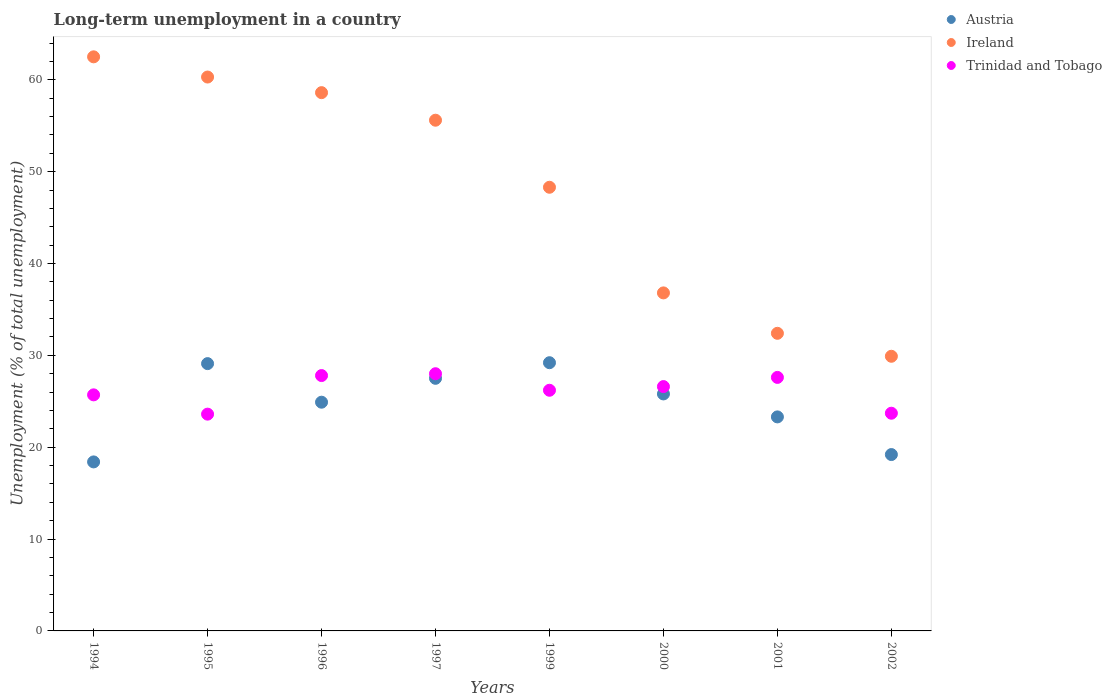Is the number of dotlines equal to the number of legend labels?
Offer a very short reply. Yes. What is the percentage of long-term unemployed population in Ireland in 1997?
Your response must be concise. 55.6. Across all years, what is the maximum percentage of long-term unemployed population in Trinidad and Tobago?
Ensure brevity in your answer.  28. Across all years, what is the minimum percentage of long-term unemployed population in Austria?
Ensure brevity in your answer.  18.4. What is the total percentage of long-term unemployed population in Trinidad and Tobago in the graph?
Make the answer very short. 209.2. What is the difference between the percentage of long-term unemployed population in Trinidad and Tobago in 2001 and that in 2002?
Offer a terse response. 3.9. What is the difference between the percentage of long-term unemployed population in Ireland in 2001 and the percentage of long-term unemployed population in Trinidad and Tobago in 1996?
Provide a succinct answer. 4.6. What is the average percentage of long-term unemployed population in Trinidad and Tobago per year?
Make the answer very short. 26.15. In the year 1994, what is the difference between the percentage of long-term unemployed population in Austria and percentage of long-term unemployed population in Trinidad and Tobago?
Provide a short and direct response. -7.3. In how many years, is the percentage of long-term unemployed population in Trinidad and Tobago greater than 26 %?
Give a very brief answer. 5. What is the ratio of the percentage of long-term unemployed population in Austria in 1999 to that in 2000?
Keep it short and to the point. 1.13. What is the difference between the highest and the second highest percentage of long-term unemployed population in Ireland?
Ensure brevity in your answer.  2.2. What is the difference between the highest and the lowest percentage of long-term unemployed population in Austria?
Provide a succinct answer. 10.8. Is the sum of the percentage of long-term unemployed population in Trinidad and Tobago in 1994 and 1999 greater than the maximum percentage of long-term unemployed population in Austria across all years?
Your answer should be compact. Yes. Does the percentage of long-term unemployed population in Ireland monotonically increase over the years?
Make the answer very short. No. Is the percentage of long-term unemployed population in Trinidad and Tobago strictly greater than the percentage of long-term unemployed population in Austria over the years?
Offer a terse response. No. Is the percentage of long-term unemployed population in Trinidad and Tobago strictly less than the percentage of long-term unemployed population in Austria over the years?
Provide a short and direct response. No. How many years are there in the graph?
Your response must be concise. 8. What is the difference between two consecutive major ticks on the Y-axis?
Offer a terse response. 10. Are the values on the major ticks of Y-axis written in scientific E-notation?
Your answer should be very brief. No. Does the graph contain grids?
Offer a terse response. No. Where does the legend appear in the graph?
Make the answer very short. Top right. How many legend labels are there?
Keep it short and to the point. 3. What is the title of the graph?
Offer a very short reply. Long-term unemployment in a country. Does "Sint Maarten (Dutch part)" appear as one of the legend labels in the graph?
Your response must be concise. No. What is the label or title of the Y-axis?
Keep it short and to the point. Unemployment (% of total unemployment). What is the Unemployment (% of total unemployment) of Austria in 1994?
Your answer should be very brief. 18.4. What is the Unemployment (% of total unemployment) of Ireland in 1994?
Provide a succinct answer. 62.5. What is the Unemployment (% of total unemployment) in Trinidad and Tobago in 1994?
Give a very brief answer. 25.7. What is the Unemployment (% of total unemployment) in Austria in 1995?
Make the answer very short. 29.1. What is the Unemployment (% of total unemployment) of Ireland in 1995?
Offer a very short reply. 60.3. What is the Unemployment (% of total unemployment) in Trinidad and Tobago in 1995?
Keep it short and to the point. 23.6. What is the Unemployment (% of total unemployment) in Austria in 1996?
Ensure brevity in your answer.  24.9. What is the Unemployment (% of total unemployment) in Ireland in 1996?
Your response must be concise. 58.6. What is the Unemployment (% of total unemployment) in Trinidad and Tobago in 1996?
Make the answer very short. 27.8. What is the Unemployment (% of total unemployment) in Ireland in 1997?
Your answer should be very brief. 55.6. What is the Unemployment (% of total unemployment) in Trinidad and Tobago in 1997?
Ensure brevity in your answer.  28. What is the Unemployment (% of total unemployment) of Austria in 1999?
Your answer should be very brief. 29.2. What is the Unemployment (% of total unemployment) in Ireland in 1999?
Make the answer very short. 48.3. What is the Unemployment (% of total unemployment) of Trinidad and Tobago in 1999?
Offer a terse response. 26.2. What is the Unemployment (% of total unemployment) of Austria in 2000?
Give a very brief answer. 25.8. What is the Unemployment (% of total unemployment) of Ireland in 2000?
Make the answer very short. 36.8. What is the Unemployment (% of total unemployment) in Trinidad and Tobago in 2000?
Your answer should be very brief. 26.6. What is the Unemployment (% of total unemployment) in Austria in 2001?
Give a very brief answer. 23.3. What is the Unemployment (% of total unemployment) of Ireland in 2001?
Your response must be concise. 32.4. What is the Unemployment (% of total unemployment) in Trinidad and Tobago in 2001?
Ensure brevity in your answer.  27.6. What is the Unemployment (% of total unemployment) in Austria in 2002?
Give a very brief answer. 19.2. What is the Unemployment (% of total unemployment) in Ireland in 2002?
Your response must be concise. 29.9. What is the Unemployment (% of total unemployment) in Trinidad and Tobago in 2002?
Offer a terse response. 23.7. Across all years, what is the maximum Unemployment (% of total unemployment) in Austria?
Provide a short and direct response. 29.2. Across all years, what is the maximum Unemployment (% of total unemployment) in Ireland?
Keep it short and to the point. 62.5. Across all years, what is the maximum Unemployment (% of total unemployment) of Trinidad and Tobago?
Your answer should be very brief. 28. Across all years, what is the minimum Unemployment (% of total unemployment) of Austria?
Ensure brevity in your answer.  18.4. Across all years, what is the minimum Unemployment (% of total unemployment) of Ireland?
Offer a very short reply. 29.9. Across all years, what is the minimum Unemployment (% of total unemployment) in Trinidad and Tobago?
Make the answer very short. 23.6. What is the total Unemployment (% of total unemployment) of Austria in the graph?
Make the answer very short. 197.4. What is the total Unemployment (% of total unemployment) of Ireland in the graph?
Provide a succinct answer. 384.4. What is the total Unemployment (% of total unemployment) in Trinidad and Tobago in the graph?
Keep it short and to the point. 209.2. What is the difference between the Unemployment (% of total unemployment) of Austria in 1994 and that in 1995?
Your answer should be compact. -10.7. What is the difference between the Unemployment (% of total unemployment) of Ireland in 1994 and that in 1995?
Provide a succinct answer. 2.2. What is the difference between the Unemployment (% of total unemployment) in Ireland in 1994 and that in 1996?
Ensure brevity in your answer.  3.9. What is the difference between the Unemployment (% of total unemployment) in Trinidad and Tobago in 1994 and that in 1996?
Provide a short and direct response. -2.1. What is the difference between the Unemployment (% of total unemployment) of Ireland in 1994 and that in 1997?
Your answer should be compact. 6.9. What is the difference between the Unemployment (% of total unemployment) in Trinidad and Tobago in 1994 and that in 1997?
Ensure brevity in your answer.  -2.3. What is the difference between the Unemployment (% of total unemployment) in Austria in 1994 and that in 1999?
Ensure brevity in your answer.  -10.8. What is the difference between the Unemployment (% of total unemployment) in Austria in 1994 and that in 2000?
Your response must be concise. -7.4. What is the difference between the Unemployment (% of total unemployment) in Ireland in 1994 and that in 2000?
Your response must be concise. 25.7. What is the difference between the Unemployment (% of total unemployment) in Trinidad and Tobago in 1994 and that in 2000?
Ensure brevity in your answer.  -0.9. What is the difference between the Unemployment (% of total unemployment) in Austria in 1994 and that in 2001?
Offer a terse response. -4.9. What is the difference between the Unemployment (% of total unemployment) in Ireland in 1994 and that in 2001?
Give a very brief answer. 30.1. What is the difference between the Unemployment (% of total unemployment) in Trinidad and Tobago in 1994 and that in 2001?
Your answer should be very brief. -1.9. What is the difference between the Unemployment (% of total unemployment) of Austria in 1994 and that in 2002?
Offer a terse response. -0.8. What is the difference between the Unemployment (% of total unemployment) in Ireland in 1994 and that in 2002?
Your response must be concise. 32.6. What is the difference between the Unemployment (% of total unemployment) in Trinidad and Tobago in 1994 and that in 2002?
Your answer should be very brief. 2. What is the difference between the Unemployment (% of total unemployment) in Austria in 1995 and that in 1996?
Offer a terse response. 4.2. What is the difference between the Unemployment (% of total unemployment) of Ireland in 1995 and that in 1996?
Your answer should be very brief. 1.7. What is the difference between the Unemployment (% of total unemployment) in Ireland in 1995 and that in 1997?
Give a very brief answer. 4.7. What is the difference between the Unemployment (% of total unemployment) in Trinidad and Tobago in 1995 and that in 1997?
Ensure brevity in your answer.  -4.4. What is the difference between the Unemployment (% of total unemployment) of Austria in 1995 and that in 1999?
Ensure brevity in your answer.  -0.1. What is the difference between the Unemployment (% of total unemployment) of Trinidad and Tobago in 1995 and that in 1999?
Provide a short and direct response. -2.6. What is the difference between the Unemployment (% of total unemployment) in Trinidad and Tobago in 1995 and that in 2000?
Ensure brevity in your answer.  -3. What is the difference between the Unemployment (% of total unemployment) in Austria in 1995 and that in 2001?
Offer a terse response. 5.8. What is the difference between the Unemployment (% of total unemployment) of Ireland in 1995 and that in 2001?
Your response must be concise. 27.9. What is the difference between the Unemployment (% of total unemployment) in Ireland in 1995 and that in 2002?
Provide a succinct answer. 30.4. What is the difference between the Unemployment (% of total unemployment) in Trinidad and Tobago in 1995 and that in 2002?
Your answer should be very brief. -0.1. What is the difference between the Unemployment (% of total unemployment) in Austria in 1996 and that in 1997?
Offer a terse response. -2.6. What is the difference between the Unemployment (% of total unemployment) of Trinidad and Tobago in 1996 and that in 1997?
Keep it short and to the point. -0.2. What is the difference between the Unemployment (% of total unemployment) in Austria in 1996 and that in 1999?
Ensure brevity in your answer.  -4.3. What is the difference between the Unemployment (% of total unemployment) of Ireland in 1996 and that in 1999?
Your response must be concise. 10.3. What is the difference between the Unemployment (% of total unemployment) in Trinidad and Tobago in 1996 and that in 1999?
Offer a terse response. 1.6. What is the difference between the Unemployment (% of total unemployment) of Austria in 1996 and that in 2000?
Ensure brevity in your answer.  -0.9. What is the difference between the Unemployment (% of total unemployment) of Ireland in 1996 and that in 2000?
Provide a short and direct response. 21.8. What is the difference between the Unemployment (% of total unemployment) of Austria in 1996 and that in 2001?
Give a very brief answer. 1.6. What is the difference between the Unemployment (% of total unemployment) of Ireland in 1996 and that in 2001?
Make the answer very short. 26.2. What is the difference between the Unemployment (% of total unemployment) in Austria in 1996 and that in 2002?
Offer a terse response. 5.7. What is the difference between the Unemployment (% of total unemployment) in Ireland in 1996 and that in 2002?
Your response must be concise. 28.7. What is the difference between the Unemployment (% of total unemployment) in Trinidad and Tobago in 1996 and that in 2002?
Your response must be concise. 4.1. What is the difference between the Unemployment (% of total unemployment) in Austria in 1997 and that in 1999?
Keep it short and to the point. -1.7. What is the difference between the Unemployment (% of total unemployment) in Ireland in 1997 and that in 1999?
Provide a succinct answer. 7.3. What is the difference between the Unemployment (% of total unemployment) of Trinidad and Tobago in 1997 and that in 1999?
Your answer should be very brief. 1.8. What is the difference between the Unemployment (% of total unemployment) in Ireland in 1997 and that in 2000?
Your answer should be very brief. 18.8. What is the difference between the Unemployment (% of total unemployment) in Austria in 1997 and that in 2001?
Your answer should be very brief. 4.2. What is the difference between the Unemployment (% of total unemployment) in Ireland in 1997 and that in 2001?
Offer a very short reply. 23.2. What is the difference between the Unemployment (% of total unemployment) in Trinidad and Tobago in 1997 and that in 2001?
Ensure brevity in your answer.  0.4. What is the difference between the Unemployment (% of total unemployment) in Ireland in 1997 and that in 2002?
Your response must be concise. 25.7. What is the difference between the Unemployment (% of total unemployment) of Austria in 1999 and that in 2000?
Give a very brief answer. 3.4. What is the difference between the Unemployment (% of total unemployment) of Ireland in 1999 and that in 2000?
Keep it short and to the point. 11.5. What is the difference between the Unemployment (% of total unemployment) in Trinidad and Tobago in 1999 and that in 2001?
Ensure brevity in your answer.  -1.4. What is the difference between the Unemployment (% of total unemployment) of Trinidad and Tobago in 1999 and that in 2002?
Your response must be concise. 2.5. What is the difference between the Unemployment (% of total unemployment) of Austria in 2000 and that in 2001?
Your response must be concise. 2.5. What is the difference between the Unemployment (% of total unemployment) in Ireland in 2000 and that in 2001?
Make the answer very short. 4.4. What is the difference between the Unemployment (% of total unemployment) of Trinidad and Tobago in 2000 and that in 2001?
Your answer should be very brief. -1. What is the difference between the Unemployment (% of total unemployment) of Ireland in 2000 and that in 2002?
Provide a succinct answer. 6.9. What is the difference between the Unemployment (% of total unemployment) in Trinidad and Tobago in 2000 and that in 2002?
Provide a succinct answer. 2.9. What is the difference between the Unemployment (% of total unemployment) in Ireland in 2001 and that in 2002?
Offer a very short reply. 2.5. What is the difference between the Unemployment (% of total unemployment) of Trinidad and Tobago in 2001 and that in 2002?
Your response must be concise. 3.9. What is the difference between the Unemployment (% of total unemployment) of Austria in 1994 and the Unemployment (% of total unemployment) of Ireland in 1995?
Offer a very short reply. -41.9. What is the difference between the Unemployment (% of total unemployment) in Austria in 1994 and the Unemployment (% of total unemployment) in Trinidad and Tobago in 1995?
Give a very brief answer. -5.2. What is the difference between the Unemployment (% of total unemployment) in Ireland in 1994 and the Unemployment (% of total unemployment) in Trinidad and Tobago in 1995?
Make the answer very short. 38.9. What is the difference between the Unemployment (% of total unemployment) of Austria in 1994 and the Unemployment (% of total unemployment) of Ireland in 1996?
Give a very brief answer. -40.2. What is the difference between the Unemployment (% of total unemployment) in Ireland in 1994 and the Unemployment (% of total unemployment) in Trinidad and Tobago in 1996?
Your response must be concise. 34.7. What is the difference between the Unemployment (% of total unemployment) of Austria in 1994 and the Unemployment (% of total unemployment) of Ireland in 1997?
Your response must be concise. -37.2. What is the difference between the Unemployment (% of total unemployment) in Ireland in 1994 and the Unemployment (% of total unemployment) in Trinidad and Tobago in 1997?
Make the answer very short. 34.5. What is the difference between the Unemployment (% of total unemployment) of Austria in 1994 and the Unemployment (% of total unemployment) of Ireland in 1999?
Your answer should be compact. -29.9. What is the difference between the Unemployment (% of total unemployment) in Ireland in 1994 and the Unemployment (% of total unemployment) in Trinidad and Tobago in 1999?
Ensure brevity in your answer.  36.3. What is the difference between the Unemployment (% of total unemployment) in Austria in 1994 and the Unemployment (% of total unemployment) in Ireland in 2000?
Provide a short and direct response. -18.4. What is the difference between the Unemployment (% of total unemployment) of Ireland in 1994 and the Unemployment (% of total unemployment) of Trinidad and Tobago in 2000?
Your answer should be compact. 35.9. What is the difference between the Unemployment (% of total unemployment) in Austria in 1994 and the Unemployment (% of total unemployment) in Trinidad and Tobago in 2001?
Offer a very short reply. -9.2. What is the difference between the Unemployment (% of total unemployment) in Ireland in 1994 and the Unemployment (% of total unemployment) in Trinidad and Tobago in 2001?
Offer a terse response. 34.9. What is the difference between the Unemployment (% of total unemployment) of Ireland in 1994 and the Unemployment (% of total unemployment) of Trinidad and Tobago in 2002?
Offer a terse response. 38.8. What is the difference between the Unemployment (% of total unemployment) of Austria in 1995 and the Unemployment (% of total unemployment) of Ireland in 1996?
Provide a succinct answer. -29.5. What is the difference between the Unemployment (% of total unemployment) of Ireland in 1995 and the Unemployment (% of total unemployment) of Trinidad and Tobago in 1996?
Your response must be concise. 32.5. What is the difference between the Unemployment (% of total unemployment) in Austria in 1995 and the Unemployment (% of total unemployment) in Ireland in 1997?
Provide a succinct answer. -26.5. What is the difference between the Unemployment (% of total unemployment) of Ireland in 1995 and the Unemployment (% of total unemployment) of Trinidad and Tobago in 1997?
Provide a short and direct response. 32.3. What is the difference between the Unemployment (% of total unemployment) in Austria in 1995 and the Unemployment (% of total unemployment) in Ireland in 1999?
Make the answer very short. -19.2. What is the difference between the Unemployment (% of total unemployment) of Ireland in 1995 and the Unemployment (% of total unemployment) of Trinidad and Tobago in 1999?
Ensure brevity in your answer.  34.1. What is the difference between the Unemployment (% of total unemployment) of Austria in 1995 and the Unemployment (% of total unemployment) of Ireland in 2000?
Ensure brevity in your answer.  -7.7. What is the difference between the Unemployment (% of total unemployment) in Austria in 1995 and the Unemployment (% of total unemployment) in Trinidad and Tobago in 2000?
Provide a short and direct response. 2.5. What is the difference between the Unemployment (% of total unemployment) of Ireland in 1995 and the Unemployment (% of total unemployment) of Trinidad and Tobago in 2000?
Keep it short and to the point. 33.7. What is the difference between the Unemployment (% of total unemployment) of Austria in 1995 and the Unemployment (% of total unemployment) of Trinidad and Tobago in 2001?
Your response must be concise. 1.5. What is the difference between the Unemployment (% of total unemployment) in Ireland in 1995 and the Unemployment (% of total unemployment) in Trinidad and Tobago in 2001?
Provide a short and direct response. 32.7. What is the difference between the Unemployment (% of total unemployment) of Ireland in 1995 and the Unemployment (% of total unemployment) of Trinidad and Tobago in 2002?
Offer a terse response. 36.6. What is the difference between the Unemployment (% of total unemployment) in Austria in 1996 and the Unemployment (% of total unemployment) in Ireland in 1997?
Ensure brevity in your answer.  -30.7. What is the difference between the Unemployment (% of total unemployment) in Austria in 1996 and the Unemployment (% of total unemployment) in Trinidad and Tobago in 1997?
Make the answer very short. -3.1. What is the difference between the Unemployment (% of total unemployment) in Ireland in 1996 and the Unemployment (% of total unemployment) in Trinidad and Tobago in 1997?
Provide a short and direct response. 30.6. What is the difference between the Unemployment (% of total unemployment) of Austria in 1996 and the Unemployment (% of total unemployment) of Ireland in 1999?
Offer a very short reply. -23.4. What is the difference between the Unemployment (% of total unemployment) in Ireland in 1996 and the Unemployment (% of total unemployment) in Trinidad and Tobago in 1999?
Provide a succinct answer. 32.4. What is the difference between the Unemployment (% of total unemployment) in Austria in 1996 and the Unemployment (% of total unemployment) in Ireland in 2002?
Ensure brevity in your answer.  -5. What is the difference between the Unemployment (% of total unemployment) of Ireland in 1996 and the Unemployment (% of total unemployment) of Trinidad and Tobago in 2002?
Your answer should be very brief. 34.9. What is the difference between the Unemployment (% of total unemployment) of Austria in 1997 and the Unemployment (% of total unemployment) of Ireland in 1999?
Provide a succinct answer. -20.8. What is the difference between the Unemployment (% of total unemployment) of Ireland in 1997 and the Unemployment (% of total unemployment) of Trinidad and Tobago in 1999?
Your answer should be compact. 29.4. What is the difference between the Unemployment (% of total unemployment) in Austria in 1997 and the Unemployment (% of total unemployment) in Trinidad and Tobago in 2000?
Provide a succinct answer. 0.9. What is the difference between the Unemployment (% of total unemployment) of Ireland in 1997 and the Unemployment (% of total unemployment) of Trinidad and Tobago in 2002?
Offer a terse response. 31.9. What is the difference between the Unemployment (% of total unemployment) in Austria in 1999 and the Unemployment (% of total unemployment) in Trinidad and Tobago in 2000?
Offer a terse response. 2.6. What is the difference between the Unemployment (% of total unemployment) of Ireland in 1999 and the Unemployment (% of total unemployment) of Trinidad and Tobago in 2000?
Your response must be concise. 21.7. What is the difference between the Unemployment (% of total unemployment) of Austria in 1999 and the Unemployment (% of total unemployment) of Ireland in 2001?
Keep it short and to the point. -3.2. What is the difference between the Unemployment (% of total unemployment) of Ireland in 1999 and the Unemployment (% of total unemployment) of Trinidad and Tobago in 2001?
Provide a short and direct response. 20.7. What is the difference between the Unemployment (% of total unemployment) of Austria in 1999 and the Unemployment (% of total unemployment) of Trinidad and Tobago in 2002?
Give a very brief answer. 5.5. What is the difference between the Unemployment (% of total unemployment) in Ireland in 1999 and the Unemployment (% of total unemployment) in Trinidad and Tobago in 2002?
Ensure brevity in your answer.  24.6. What is the difference between the Unemployment (% of total unemployment) in Austria in 2000 and the Unemployment (% of total unemployment) in Trinidad and Tobago in 2001?
Keep it short and to the point. -1.8. What is the difference between the Unemployment (% of total unemployment) of Ireland in 2000 and the Unemployment (% of total unemployment) of Trinidad and Tobago in 2001?
Your response must be concise. 9.2. What is the difference between the Unemployment (% of total unemployment) of Austria in 2001 and the Unemployment (% of total unemployment) of Ireland in 2002?
Your answer should be very brief. -6.6. What is the difference between the Unemployment (% of total unemployment) of Austria in 2001 and the Unemployment (% of total unemployment) of Trinidad and Tobago in 2002?
Your response must be concise. -0.4. What is the difference between the Unemployment (% of total unemployment) of Ireland in 2001 and the Unemployment (% of total unemployment) of Trinidad and Tobago in 2002?
Make the answer very short. 8.7. What is the average Unemployment (% of total unemployment) of Austria per year?
Give a very brief answer. 24.68. What is the average Unemployment (% of total unemployment) of Ireland per year?
Keep it short and to the point. 48.05. What is the average Unemployment (% of total unemployment) in Trinidad and Tobago per year?
Your response must be concise. 26.15. In the year 1994, what is the difference between the Unemployment (% of total unemployment) in Austria and Unemployment (% of total unemployment) in Ireland?
Your answer should be very brief. -44.1. In the year 1994, what is the difference between the Unemployment (% of total unemployment) of Ireland and Unemployment (% of total unemployment) of Trinidad and Tobago?
Your answer should be very brief. 36.8. In the year 1995, what is the difference between the Unemployment (% of total unemployment) of Austria and Unemployment (% of total unemployment) of Ireland?
Ensure brevity in your answer.  -31.2. In the year 1995, what is the difference between the Unemployment (% of total unemployment) of Austria and Unemployment (% of total unemployment) of Trinidad and Tobago?
Offer a very short reply. 5.5. In the year 1995, what is the difference between the Unemployment (% of total unemployment) in Ireland and Unemployment (% of total unemployment) in Trinidad and Tobago?
Your answer should be very brief. 36.7. In the year 1996, what is the difference between the Unemployment (% of total unemployment) in Austria and Unemployment (% of total unemployment) in Ireland?
Your answer should be very brief. -33.7. In the year 1996, what is the difference between the Unemployment (% of total unemployment) in Ireland and Unemployment (% of total unemployment) in Trinidad and Tobago?
Provide a succinct answer. 30.8. In the year 1997, what is the difference between the Unemployment (% of total unemployment) in Austria and Unemployment (% of total unemployment) in Ireland?
Make the answer very short. -28.1. In the year 1997, what is the difference between the Unemployment (% of total unemployment) in Ireland and Unemployment (% of total unemployment) in Trinidad and Tobago?
Make the answer very short. 27.6. In the year 1999, what is the difference between the Unemployment (% of total unemployment) of Austria and Unemployment (% of total unemployment) of Ireland?
Your answer should be very brief. -19.1. In the year 1999, what is the difference between the Unemployment (% of total unemployment) in Ireland and Unemployment (% of total unemployment) in Trinidad and Tobago?
Offer a terse response. 22.1. In the year 2000, what is the difference between the Unemployment (% of total unemployment) of Austria and Unemployment (% of total unemployment) of Ireland?
Keep it short and to the point. -11. In the year 2001, what is the difference between the Unemployment (% of total unemployment) of Ireland and Unemployment (% of total unemployment) of Trinidad and Tobago?
Keep it short and to the point. 4.8. In the year 2002, what is the difference between the Unemployment (% of total unemployment) in Ireland and Unemployment (% of total unemployment) in Trinidad and Tobago?
Provide a short and direct response. 6.2. What is the ratio of the Unemployment (% of total unemployment) in Austria in 1994 to that in 1995?
Offer a very short reply. 0.63. What is the ratio of the Unemployment (% of total unemployment) of Ireland in 1994 to that in 1995?
Your answer should be very brief. 1.04. What is the ratio of the Unemployment (% of total unemployment) of Trinidad and Tobago in 1994 to that in 1995?
Your answer should be compact. 1.09. What is the ratio of the Unemployment (% of total unemployment) of Austria in 1994 to that in 1996?
Offer a very short reply. 0.74. What is the ratio of the Unemployment (% of total unemployment) of Ireland in 1994 to that in 1996?
Ensure brevity in your answer.  1.07. What is the ratio of the Unemployment (% of total unemployment) of Trinidad and Tobago in 1994 to that in 1996?
Give a very brief answer. 0.92. What is the ratio of the Unemployment (% of total unemployment) in Austria in 1994 to that in 1997?
Your response must be concise. 0.67. What is the ratio of the Unemployment (% of total unemployment) of Ireland in 1994 to that in 1997?
Offer a terse response. 1.12. What is the ratio of the Unemployment (% of total unemployment) in Trinidad and Tobago in 1994 to that in 1997?
Ensure brevity in your answer.  0.92. What is the ratio of the Unemployment (% of total unemployment) in Austria in 1994 to that in 1999?
Provide a short and direct response. 0.63. What is the ratio of the Unemployment (% of total unemployment) in Ireland in 1994 to that in 1999?
Give a very brief answer. 1.29. What is the ratio of the Unemployment (% of total unemployment) of Trinidad and Tobago in 1994 to that in 1999?
Give a very brief answer. 0.98. What is the ratio of the Unemployment (% of total unemployment) in Austria in 1994 to that in 2000?
Provide a succinct answer. 0.71. What is the ratio of the Unemployment (% of total unemployment) of Ireland in 1994 to that in 2000?
Your answer should be compact. 1.7. What is the ratio of the Unemployment (% of total unemployment) of Trinidad and Tobago in 1994 to that in 2000?
Offer a terse response. 0.97. What is the ratio of the Unemployment (% of total unemployment) of Austria in 1994 to that in 2001?
Make the answer very short. 0.79. What is the ratio of the Unemployment (% of total unemployment) of Ireland in 1994 to that in 2001?
Your answer should be very brief. 1.93. What is the ratio of the Unemployment (% of total unemployment) in Trinidad and Tobago in 1994 to that in 2001?
Provide a succinct answer. 0.93. What is the ratio of the Unemployment (% of total unemployment) in Ireland in 1994 to that in 2002?
Ensure brevity in your answer.  2.09. What is the ratio of the Unemployment (% of total unemployment) in Trinidad and Tobago in 1994 to that in 2002?
Give a very brief answer. 1.08. What is the ratio of the Unemployment (% of total unemployment) in Austria in 1995 to that in 1996?
Keep it short and to the point. 1.17. What is the ratio of the Unemployment (% of total unemployment) in Trinidad and Tobago in 1995 to that in 1996?
Make the answer very short. 0.85. What is the ratio of the Unemployment (% of total unemployment) in Austria in 1995 to that in 1997?
Keep it short and to the point. 1.06. What is the ratio of the Unemployment (% of total unemployment) of Ireland in 1995 to that in 1997?
Give a very brief answer. 1.08. What is the ratio of the Unemployment (% of total unemployment) of Trinidad and Tobago in 1995 to that in 1997?
Give a very brief answer. 0.84. What is the ratio of the Unemployment (% of total unemployment) of Austria in 1995 to that in 1999?
Ensure brevity in your answer.  1. What is the ratio of the Unemployment (% of total unemployment) of Ireland in 1995 to that in 1999?
Offer a very short reply. 1.25. What is the ratio of the Unemployment (% of total unemployment) of Trinidad and Tobago in 1995 to that in 1999?
Offer a very short reply. 0.9. What is the ratio of the Unemployment (% of total unemployment) of Austria in 1995 to that in 2000?
Ensure brevity in your answer.  1.13. What is the ratio of the Unemployment (% of total unemployment) in Ireland in 1995 to that in 2000?
Keep it short and to the point. 1.64. What is the ratio of the Unemployment (% of total unemployment) in Trinidad and Tobago in 1995 to that in 2000?
Ensure brevity in your answer.  0.89. What is the ratio of the Unemployment (% of total unemployment) of Austria in 1995 to that in 2001?
Offer a terse response. 1.25. What is the ratio of the Unemployment (% of total unemployment) in Ireland in 1995 to that in 2001?
Your answer should be compact. 1.86. What is the ratio of the Unemployment (% of total unemployment) in Trinidad and Tobago in 1995 to that in 2001?
Provide a short and direct response. 0.86. What is the ratio of the Unemployment (% of total unemployment) in Austria in 1995 to that in 2002?
Provide a succinct answer. 1.52. What is the ratio of the Unemployment (% of total unemployment) in Ireland in 1995 to that in 2002?
Your answer should be very brief. 2.02. What is the ratio of the Unemployment (% of total unemployment) of Austria in 1996 to that in 1997?
Provide a succinct answer. 0.91. What is the ratio of the Unemployment (% of total unemployment) in Ireland in 1996 to that in 1997?
Give a very brief answer. 1.05. What is the ratio of the Unemployment (% of total unemployment) of Austria in 1996 to that in 1999?
Your answer should be compact. 0.85. What is the ratio of the Unemployment (% of total unemployment) in Ireland in 1996 to that in 1999?
Your answer should be compact. 1.21. What is the ratio of the Unemployment (% of total unemployment) of Trinidad and Tobago in 1996 to that in 1999?
Offer a very short reply. 1.06. What is the ratio of the Unemployment (% of total unemployment) in Austria in 1996 to that in 2000?
Provide a short and direct response. 0.97. What is the ratio of the Unemployment (% of total unemployment) in Ireland in 1996 to that in 2000?
Ensure brevity in your answer.  1.59. What is the ratio of the Unemployment (% of total unemployment) in Trinidad and Tobago in 1996 to that in 2000?
Offer a terse response. 1.05. What is the ratio of the Unemployment (% of total unemployment) in Austria in 1996 to that in 2001?
Your answer should be very brief. 1.07. What is the ratio of the Unemployment (% of total unemployment) of Ireland in 1996 to that in 2001?
Give a very brief answer. 1.81. What is the ratio of the Unemployment (% of total unemployment) in Trinidad and Tobago in 1996 to that in 2001?
Your response must be concise. 1.01. What is the ratio of the Unemployment (% of total unemployment) of Austria in 1996 to that in 2002?
Your answer should be compact. 1.3. What is the ratio of the Unemployment (% of total unemployment) in Ireland in 1996 to that in 2002?
Your response must be concise. 1.96. What is the ratio of the Unemployment (% of total unemployment) of Trinidad and Tobago in 1996 to that in 2002?
Make the answer very short. 1.17. What is the ratio of the Unemployment (% of total unemployment) in Austria in 1997 to that in 1999?
Keep it short and to the point. 0.94. What is the ratio of the Unemployment (% of total unemployment) in Ireland in 1997 to that in 1999?
Offer a terse response. 1.15. What is the ratio of the Unemployment (% of total unemployment) in Trinidad and Tobago in 1997 to that in 1999?
Provide a short and direct response. 1.07. What is the ratio of the Unemployment (% of total unemployment) of Austria in 1997 to that in 2000?
Ensure brevity in your answer.  1.07. What is the ratio of the Unemployment (% of total unemployment) of Ireland in 1997 to that in 2000?
Offer a terse response. 1.51. What is the ratio of the Unemployment (% of total unemployment) in Trinidad and Tobago in 1997 to that in 2000?
Keep it short and to the point. 1.05. What is the ratio of the Unemployment (% of total unemployment) in Austria in 1997 to that in 2001?
Offer a very short reply. 1.18. What is the ratio of the Unemployment (% of total unemployment) of Ireland in 1997 to that in 2001?
Give a very brief answer. 1.72. What is the ratio of the Unemployment (% of total unemployment) in Trinidad and Tobago in 1997 to that in 2001?
Offer a terse response. 1.01. What is the ratio of the Unemployment (% of total unemployment) of Austria in 1997 to that in 2002?
Give a very brief answer. 1.43. What is the ratio of the Unemployment (% of total unemployment) in Ireland in 1997 to that in 2002?
Offer a terse response. 1.86. What is the ratio of the Unemployment (% of total unemployment) of Trinidad and Tobago in 1997 to that in 2002?
Ensure brevity in your answer.  1.18. What is the ratio of the Unemployment (% of total unemployment) in Austria in 1999 to that in 2000?
Your answer should be very brief. 1.13. What is the ratio of the Unemployment (% of total unemployment) in Ireland in 1999 to that in 2000?
Provide a short and direct response. 1.31. What is the ratio of the Unemployment (% of total unemployment) in Austria in 1999 to that in 2001?
Provide a succinct answer. 1.25. What is the ratio of the Unemployment (% of total unemployment) of Ireland in 1999 to that in 2001?
Ensure brevity in your answer.  1.49. What is the ratio of the Unemployment (% of total unemployment) in Trinidad and Tobago in 1999 to that in 2001?
Offer a very short reply. 0.95. What is the ratio of the Unemployment (% of total unemployment) in Austria in 1999 to that in 2002?
Give a very brief answer. 1.52. What is the ratio of the Unemployment (% of total unemployment) in Ireland in 1999 to that in 2002?
Make the answer very short. 1.62. What is the ratio of the Unemployment (% of total unemployment) of Trinidad and Tobago in 1999 to that in 2002?
Offer a terse response. 1.11. What is the ratio of the Unemployment (% of total unemployment) of Austria in 2000 to that in 2001?
Provide a short and direct response. 1.11. What is the ratio of the Unemployment (% of total unemployment) of Ireland in 2000 to that in 2001?
Offer a terse response. 1.14. What is the ratio of the Unemployment (% of total unemployment) of Trinidad and Tobago in 2000 to that in 2001?
Provide a succinct answer. 0.96. What is the ratio of the Unemployment (% of total unemployment) in Austria in 2000 to that in 2002?
Your answer should be very brief. 1.34. What is the ratio of the Unemployment (% of total unemployment) in Ireland in 2000 to that in 2002?
Make the answer very short. 1.23. What is the ratio of the Unemployment (% of total unemployment) of Trinidad and Tobago in 2000 to that in 2002?
Your answer should be compact. 1.12. What is the ratio of the Unemployment (% of total unemployment) in Austria in 2001 to that in 2002?
Offer a terse response. 1.21. What is the ratio of the Unemployment (% of total unemployment) of Ireland in 2001 to that in 2002?
Ensure brevity in your answer.  1.08. What is the ratio of the Unemployment (% of total unemployment) of Trinidad and Tobago in 2001 to that in 2002?
Make the answer very short. 1.16. What is the difference between the highest and the second highest Unemployment (% of total unemployment) in Austria?
Offer a very short reply. 0.1. What is the difference between the highest and the second highest Unemployment (% of total unemployment) of Trinidad and Tobago?
Provide a short and direct response. 0.2. What is the difference between the highest and the lowest Unemployment (% of total unemployment) in Ireland?
Your answer should be very brief. 32.6. 